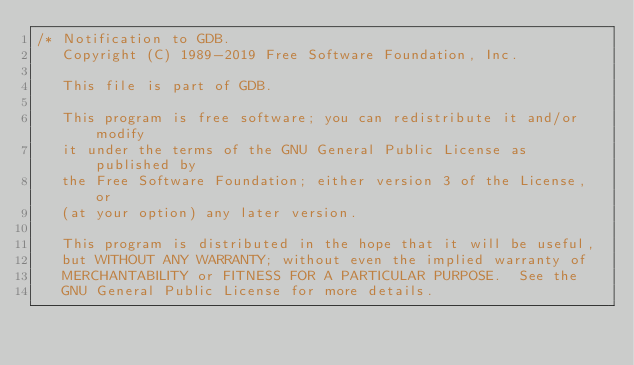<code> <loc_0><loc_0><loc_500><loc_500><_C_>/* Notification to GDB.
   Copyright (C) 1989-2019 Free Software Foundation, Inc.

   This file is part of GDB.

   This program is free software; you can redistribute it and/or modify
   it under the terms of the GNU General Public License as published by
   the Free Software Foundation; either version 3 of the License, or
   (at your option) any later version.

   This program is distributed in the hope that it will be useful,
   but WITHOUT ANY WARRANTY; without even the implied warranty of
   MERCHANTABILITY or FITNESS FOR A PARTICULAR PURPOSE.  See the
   GNU General Public License for more details.
</code> 